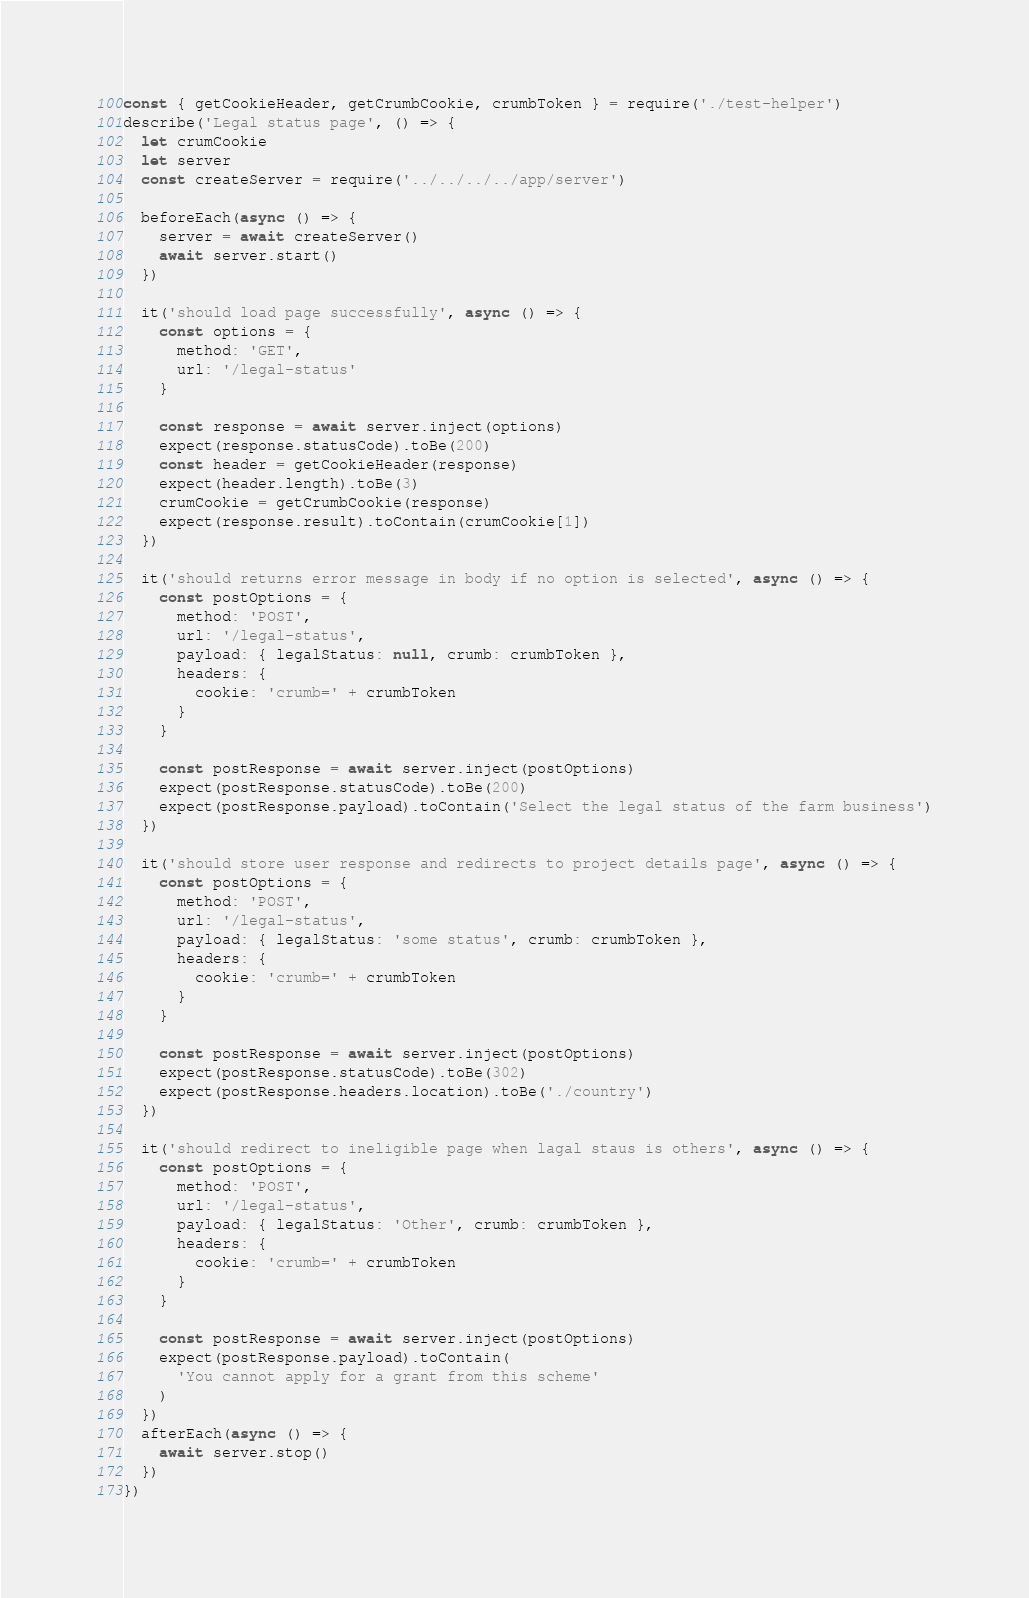<code> <loc_0><loc_0><loc_500><loc_500><_JavaScript_>const { getCookieHeader, getCrumbCookie, crumbToken } = require('./test-helper')
describe('Legal status page', () => {
  let crumCookie
  let server
  const createServer = require('../../../../app/server')

  beforeEach(async () => {
    server = await createServer()
    await server.start()
  })

  it('should load page successfully', async () => {
    const options = {
      method: 'GET',
      url: '/legal-status'
    }

    const response = await server.inject(options)
    expect(response.statusCode).toBe(200)
    const header = getCookieHeader(response)
    expect(header.length).toBe(3)
    crumCookie = getCrumbCookie(response)
    expect(response.result).toContain(crumCookie[1])
  })

  it('should returns error message in body if no option is selected', async () => {
    const postOptions = {
      method: 'POST',
      url: '/legal-status',
      payload: { legalStatus: null, crumb: crumbToken },
      headers: {
        cookie: 'crumb=' + crumbToken
      }
    }

    const postResponse = await server.inject(postOptions)
    expect(postResponse.statusCode).toBe(200)
    expect(postResponse.payload).toContain('Select the legal status of the farm business')
  })

  it('should store user response and redirects to project details page', async () => {
    const postOptions = {
      method: 'POST',
      url: '/legal-status',
      payload: { legalStatus: 'some status', crumb: crumbToken },
      headers: {
        cookie: 'crumb=' + crumbToken
      }
    }

    const postResponse = await server.inject(postOptions)
    expect(postResponse.statusCode).toBe(302)
    expect(postResponse.headers.location).toBe('./country')
  })

  it('should redirect to ineligible page when lagal staus is others', async () => {
    const postOptions = {
      method: 'POST',
      url: '/legal-status',
      payload: { legalStatus: 'Other', crumb: crumbToken },
      headers: {
        cookie: 'crumb=' + crumbToken
      }
    }

    const postResponse = await server.inject(postOptions)
    expect(postResponse.payload).toContain(
      'You cannot apply for a grant from this scheme'
    )
  })
  afterEach(async () => {
    await server.stop()
  })
})
</code> 